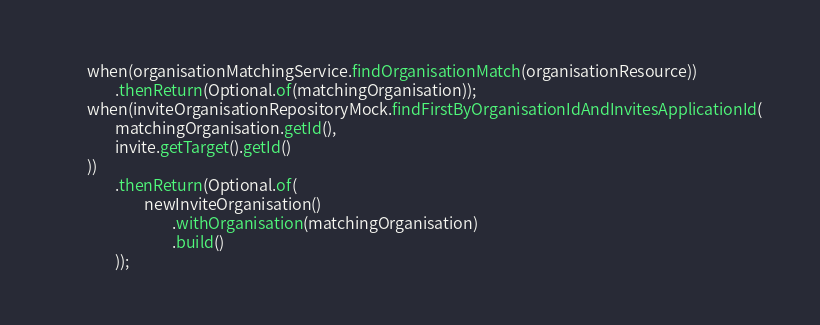Convert code to text. <code><loc_0><loc_0><loc_500><loc_500><_Java_>        when(organisationMatchingService.findOrganisationMatch(organisationResource))
                .thenReturn(Optional.of(matchingOrganisation));
        when(inviteOrganisationRepositoryMock.findFirstByOrganisationIdAndInvitesApplicationId(
                matchingOrganisation.getId(),
                invite.getTarget().getId()
        ))
                .thenReturn(Optional.of(
                        newInviteOrganisation()
                                .withOrganisation(matchingOrganisation)
                                .build()
                ));
</code> 